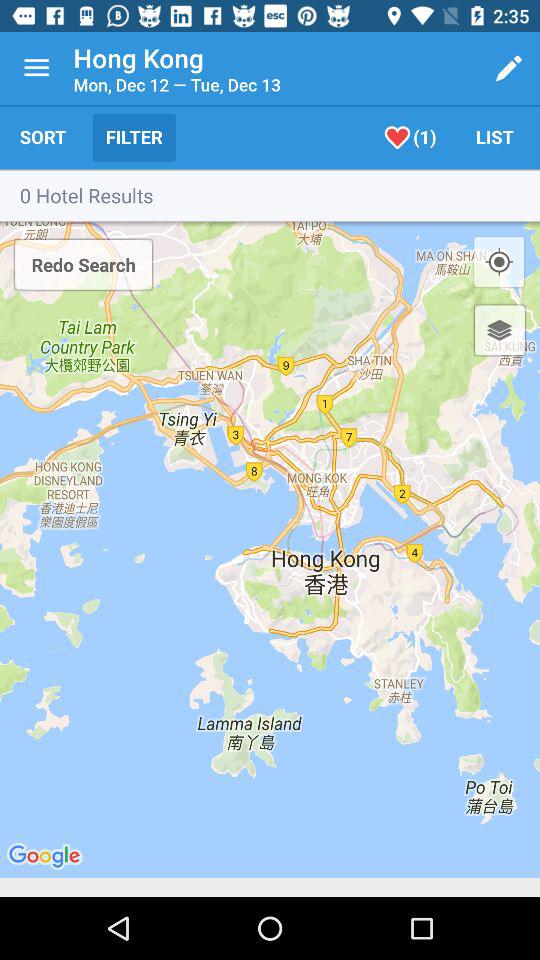How many likes are there of the map? There is 1 like. 